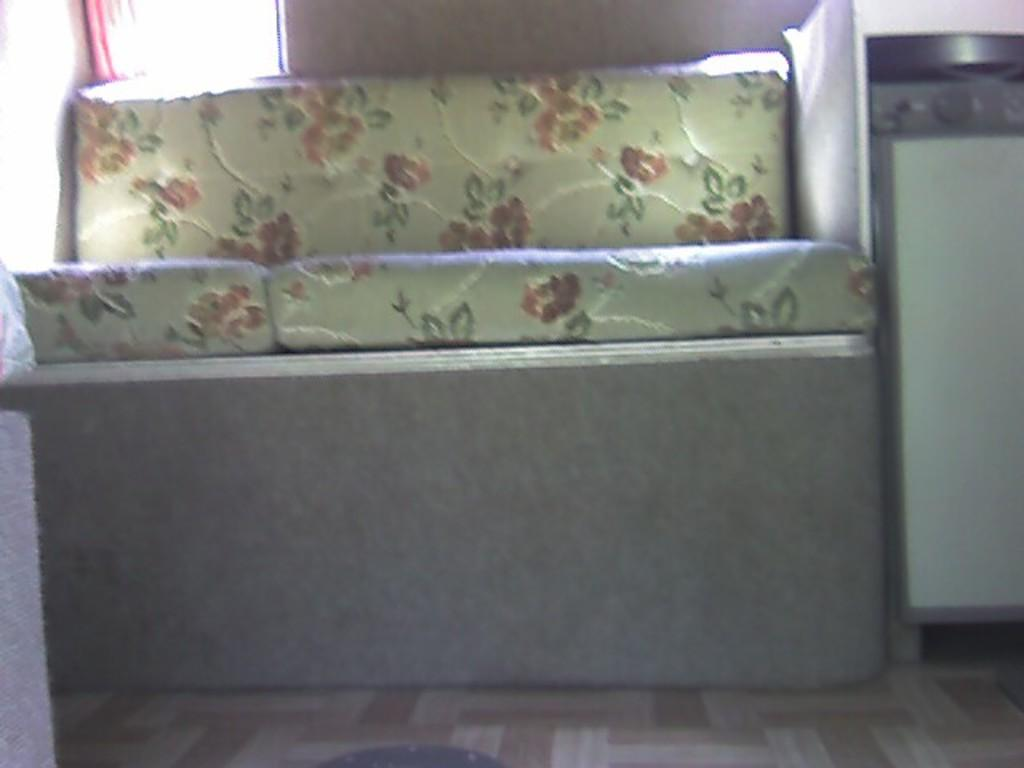What type of furniture is present in the image? There is a sofa in the image. What appliance can be seen on the right side of the image? There is a stove on the right side of the image. What type of window treatment is visible in the background of the image? There is a curtain in the background of the image. What color is the daughter's lipstick in the image? There is no daughter present in the image, so we cannot determine the color of her lipstick. Can you describe the sidewalk outside the window in the image? There is no sidewalk visible in the image; it only shows a sofa, a stove, and a curtain. 